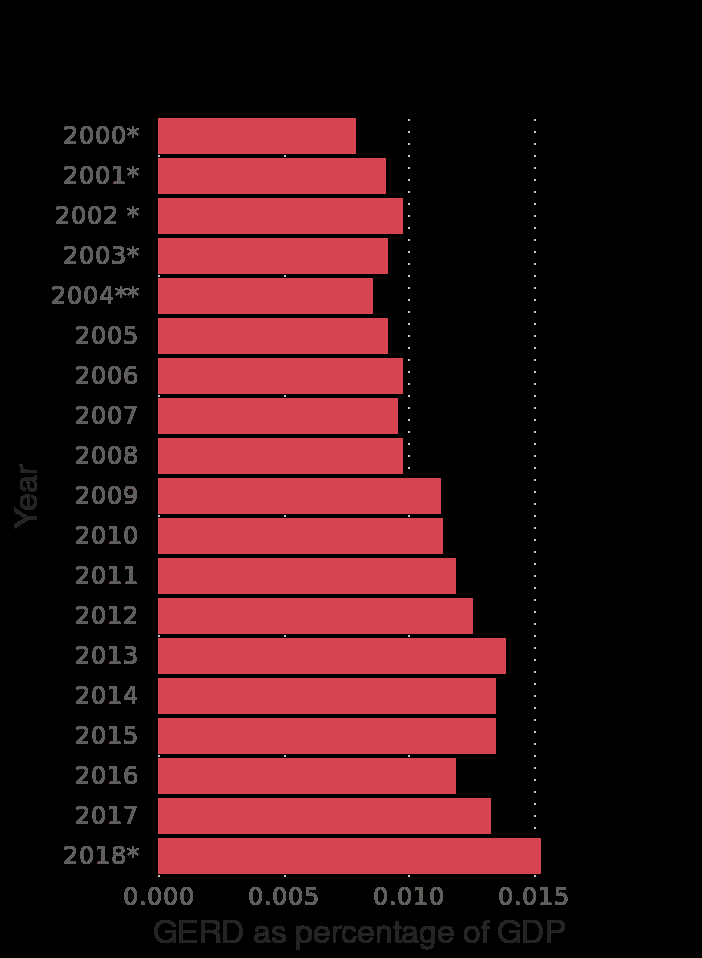<image>
What was the percentage in 2018?  The percentage was 0.014 in 2018. 